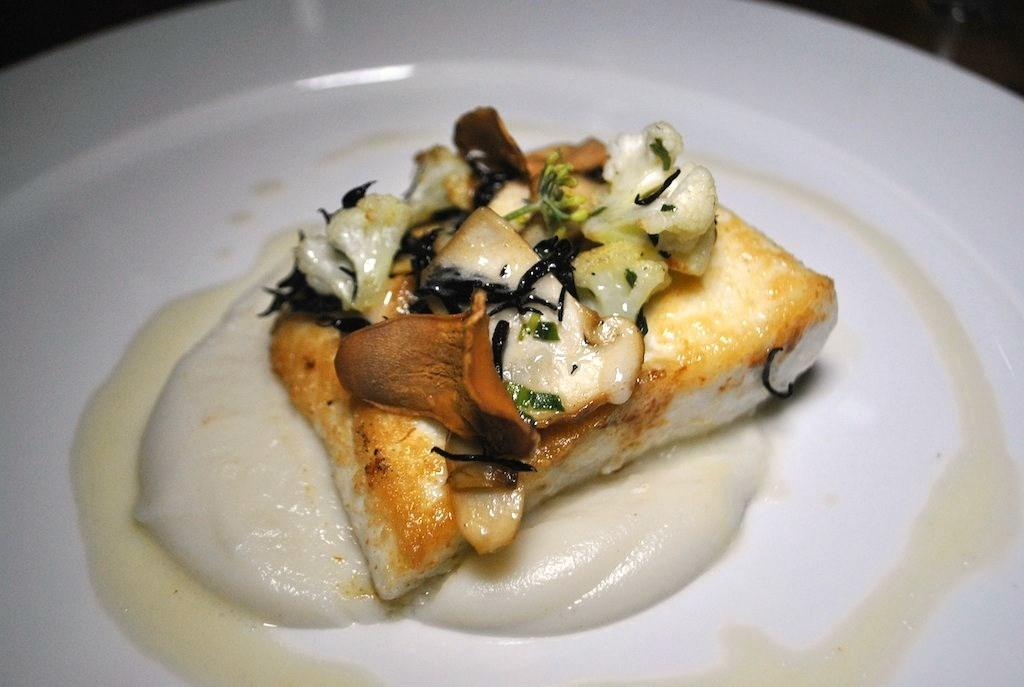What is the main subject of the image? There is a food item in the image. How is the food item presented in the image? The food item is served on a plate. What type of calculator can be seen on the plate in the image? There is no calculator present in the image. The image only shows a food item served on a plate. 